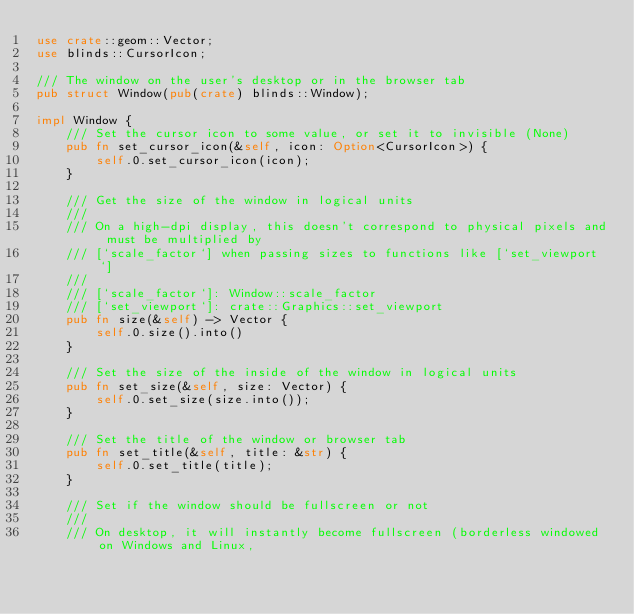Convert code to text. <code><loc_0><loc_0><loc_500><loc_500><_Rust_>use crate::geom::Vector;
use blinds::CursorIcon;

/// The window on the user's desktop or in the browser tab
pub struct Window(pub(crate) blinds::Window);

impl Window {
    /// Set the cursor icon to some value, or set it to invisible (None)
    pub fn set_cursor_icon(&self, icon: Option<CursorIcon>) {
        self.0.set_cursor_icon(icon);
    }

    /// Get the size of the window in logical units
    ///
    /// On a high-dpi display, this doesn't correspond to physical pixels and must be multiplied by
    /// [`scale_factor`] when passing sizes to functions like [`set_viewport`]
    ///
    /// [`scale_factor`]: Window::scale_factor
    /// [`set_viewport`]: crate::Graphics::set_viewport
    pub fn size(&self) -> Vector {
        self.0.size().into()
    }

    /// Set the size of the inside of the window in logical units
    pub fn set_size(&self, size: Vector) {
        self.0.set_size(size.into());
    }

    /// Set the title of the window or browser tab
    pub fn set_title(&self, title: &str) {
        self.0.set_title(title);
    }

    /// Set if the window should be fullscreen or not
    ///
    /// On desktop, it will instantly become fullscreen (borderless windowed on Windows and Linux,</code> 